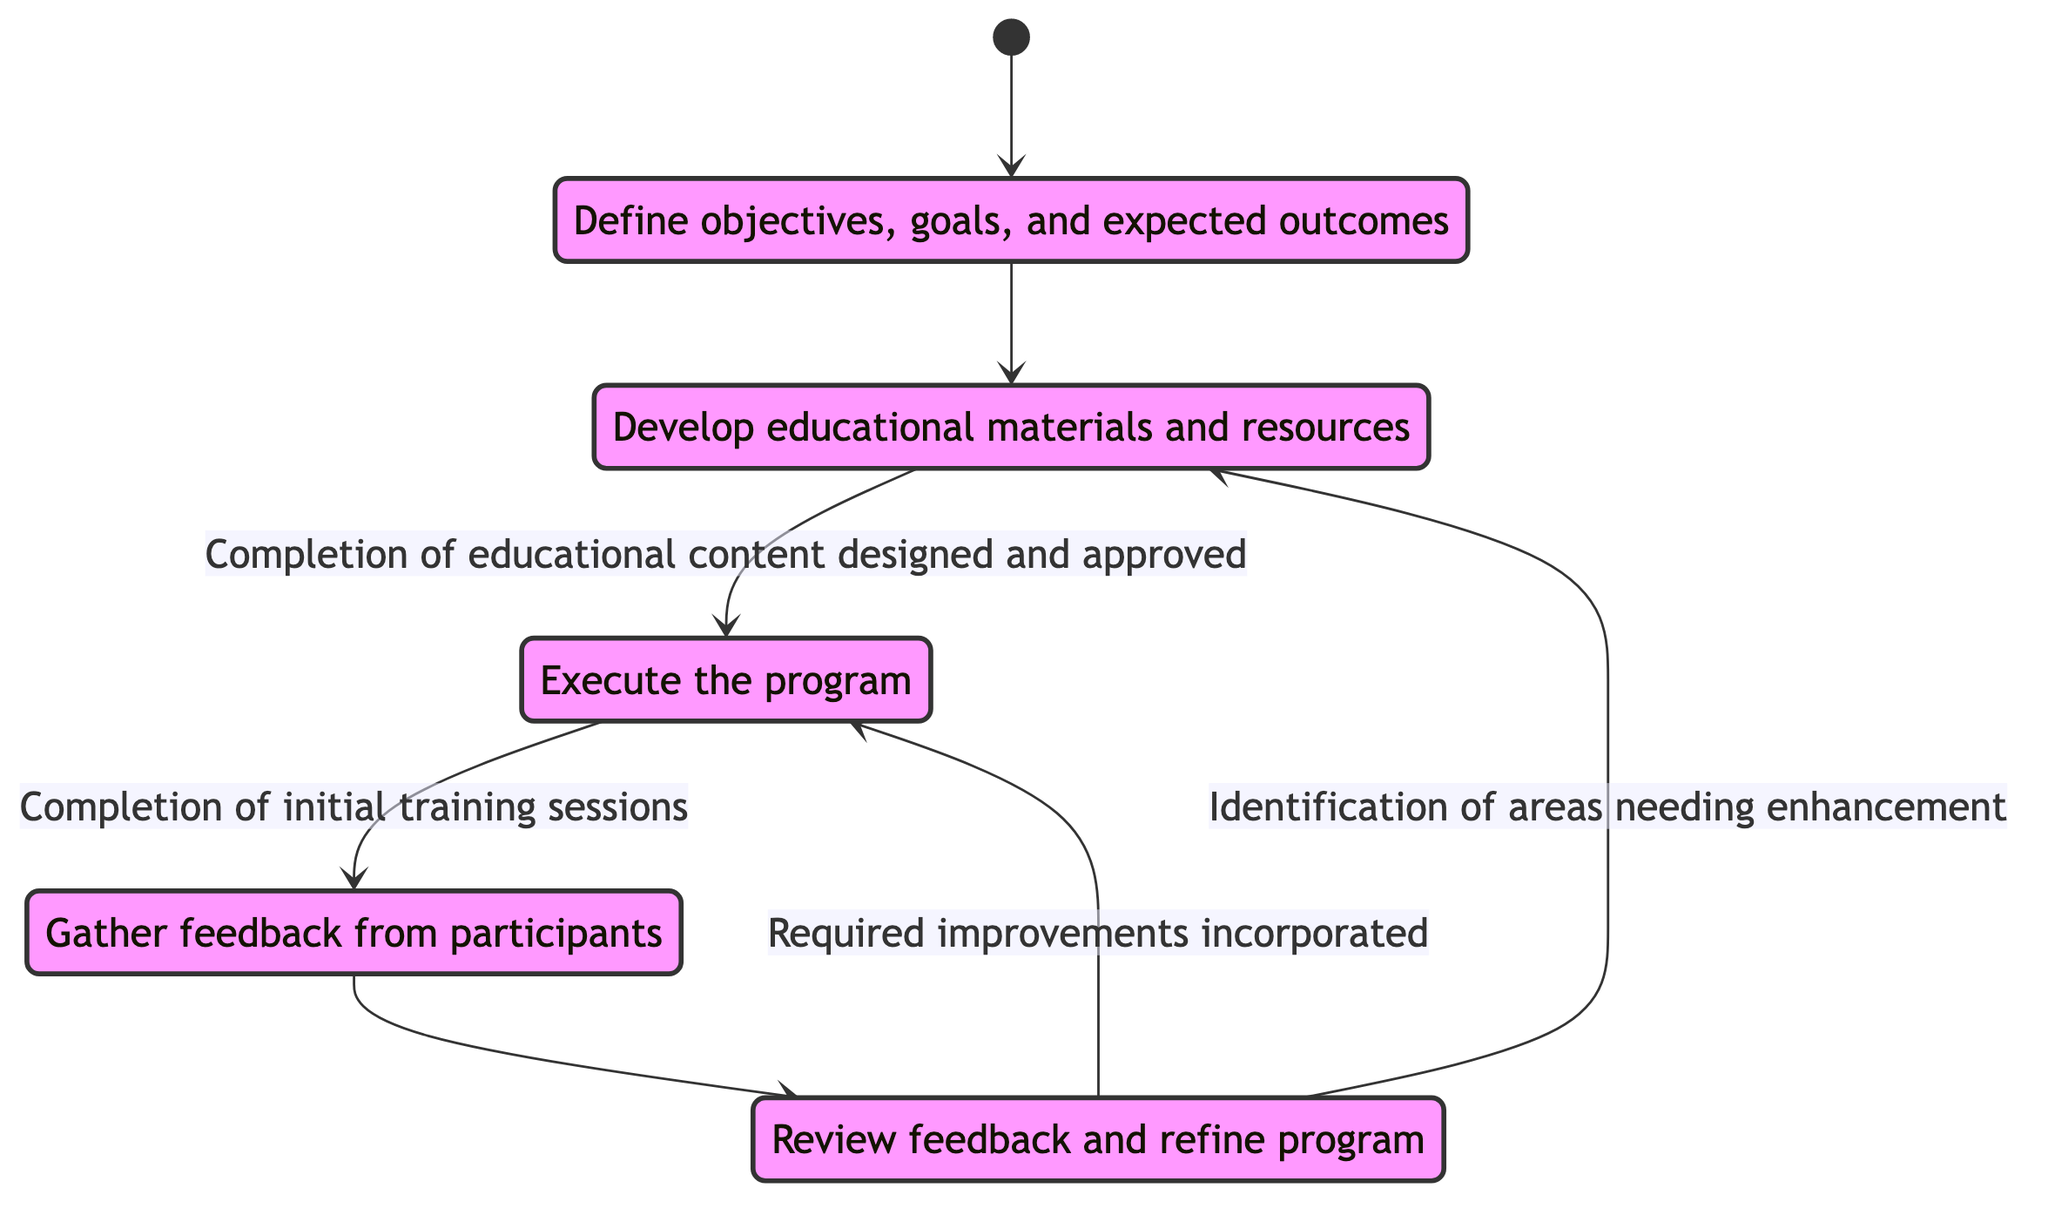What is the first state in the faculty development program? The first state is represented by the initial transition from [*] leading to Initial_Planning in the diagram. This defines where the process begins.
Answer: Initial Planning How many total states are represented in the diagram? By counting each distinct labeled state in the diagram, we find there are five: Initial_Planning, Content_Creation, Implementation, Feedback_Collection, and Improvement.
Answer: 5 What is the last state in the faculty development program? The flow of the diagram indicates that the process can return to either Content Creation or Implementation after Improvement, but it does not terminate at a final state. Thus, it effectively loops back to earlier stages.
Answer: Improvement Which state comes after Content Creation? From the diagram, Content_Creation has a directed transition to Implementation, triggered by the condition of content completion and approval, indicating its sequential relationship in the flow.
Answer: Implementation What condition leads to the transition from Implementation to Feedback Collection? The condition stated in the diagram that triggers this transition is the 'Completion of initial training sessions,' marking an essential milestone between these two states.
Answer: Completion of initial training sessions Which two states can Improvement transition to? Improvement can lead back to Content_Creation or go forward to Implementation based on different conditions in the diagram. This reflects the iterative nature of development based on feedback.
Answer: Content Creation and Implementation What is the primary purpose of the Initial Planning state? The diagram describes the role of Initial_Planning as defining objectives, goals, and expected outcomes, setting the foundation for the program's success.
Answer: Define objectives, goals, and expected outcomes How does the flow change if feedback identifies areas needing enhancement? If feedback identifies areas needing enhancement, the flow redirects to Content_Creation to revise the materials, before reconsidering implementation based on those improvements.
Answer: Redirects to Content Creation What type of feedback is collected in the Feedback Collection state? Feedback is gathered from participants through surveys, interviews, and observation forms as indicated in the description of the Feedback_Collection state.
Answer: Surveys, interviews, and observation forms 